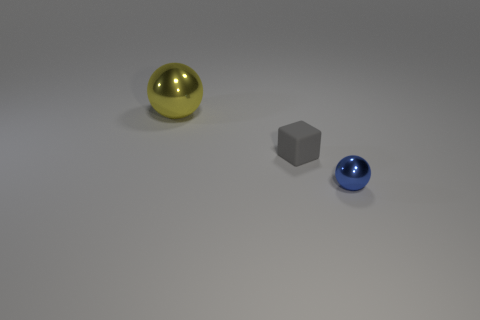Are there any other things that are made of the same material as the tiny cube?
Your answer should be compact. No. Does the metal object that is right of the large thing have the same shape as the object that is behind the small gray rubber cube?
Your answer should be very brief. Yes. The object that is the same size as the blue ball is what shape?
Offer a very short reply. Cube. Does the sphere right of the big metal ball have the same material as the sphere that is to the left of the small blue shiny ball?
Give a very brief answer. Yes. Is there a blue shiny object that is on the right side of the sphere that is to the right of the big object?
Provide a succinct answer. No. The big thing that is the same material as the small blue thing is what color?
Offer a very short reply. Yellow. Are there more large shiny spheres than spheres?
Make the answer very short. No. What number of objects are spheres that are behind the tiny ball or large purple matte cylinders?
Your answer should be compact. 1. Are there any spheres that have the same size as the yellow metallic thing?
Your answer should be compact. No. Is the number of tiny gray rubber cubes less than the number of large red cylinders?
Your answer should be very brief. No. 